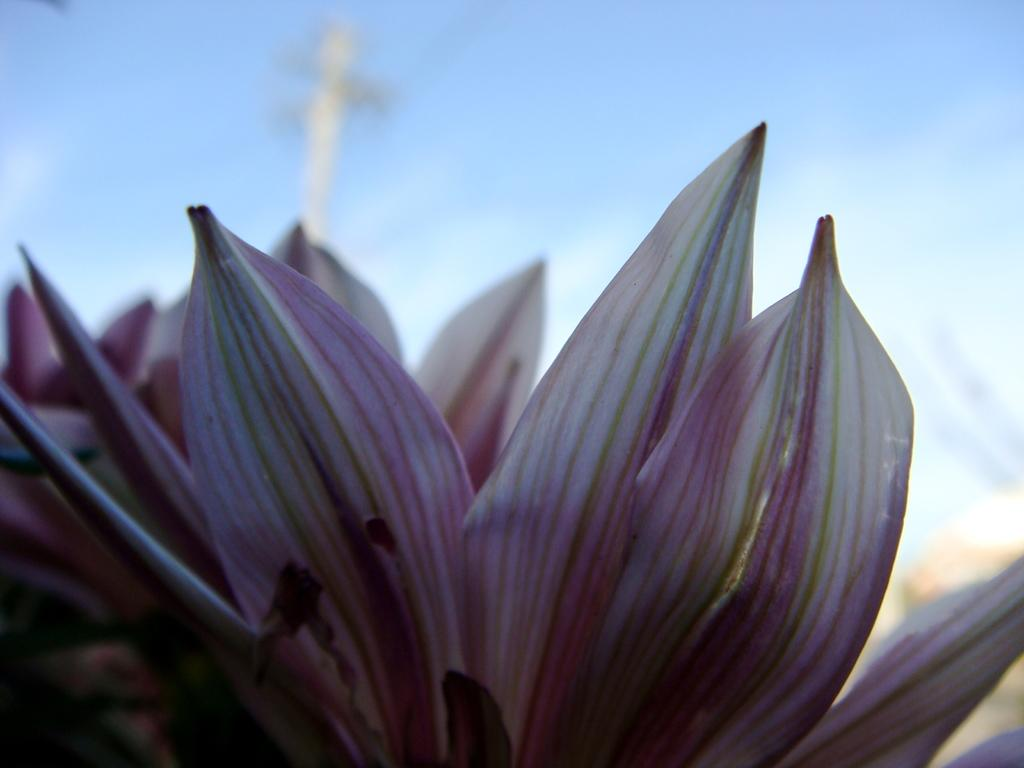What is the main subject of the image? The main subject of the image is a flower. What can be seen in the background of the image? The sky is visible at the top of the image. Can you see any bears eating cherries in the image? There are no bears or cherries present in the image; it features a flower and the sky. 